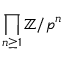Convert formula to latex. <formula><loc_0><loc_0><loc_500><loc_500>\prod _ { n \geq 1 } \mathbb { Z } / p ^ { n }</formula> 